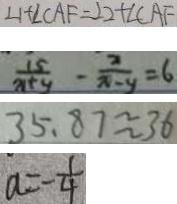Convert formula to latex. <formula><loc_0><loc_0><loc_500><loc_500>\angle 1 + \angle C A F = \angle 2 + \angle C A F 
 \frac { 1 5 } { x + y } - \frac { 2 } { x - y } = 6 
 3 5 . 8 7 \approx 3 6 
 a = - \frac { 1 } { 4 }</formula> 